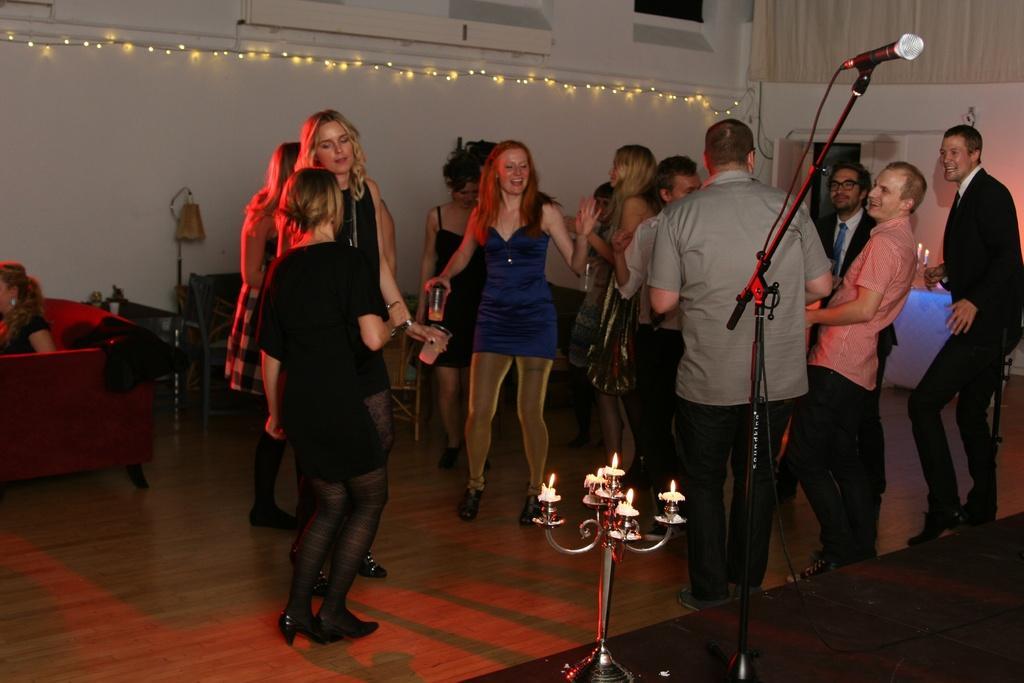How would you summarize this image in a sentence or two? In this image there are a group of people dancing in the room, beside them there is a mike stand and candle stand, also there is another girl sitting on the sofa. 